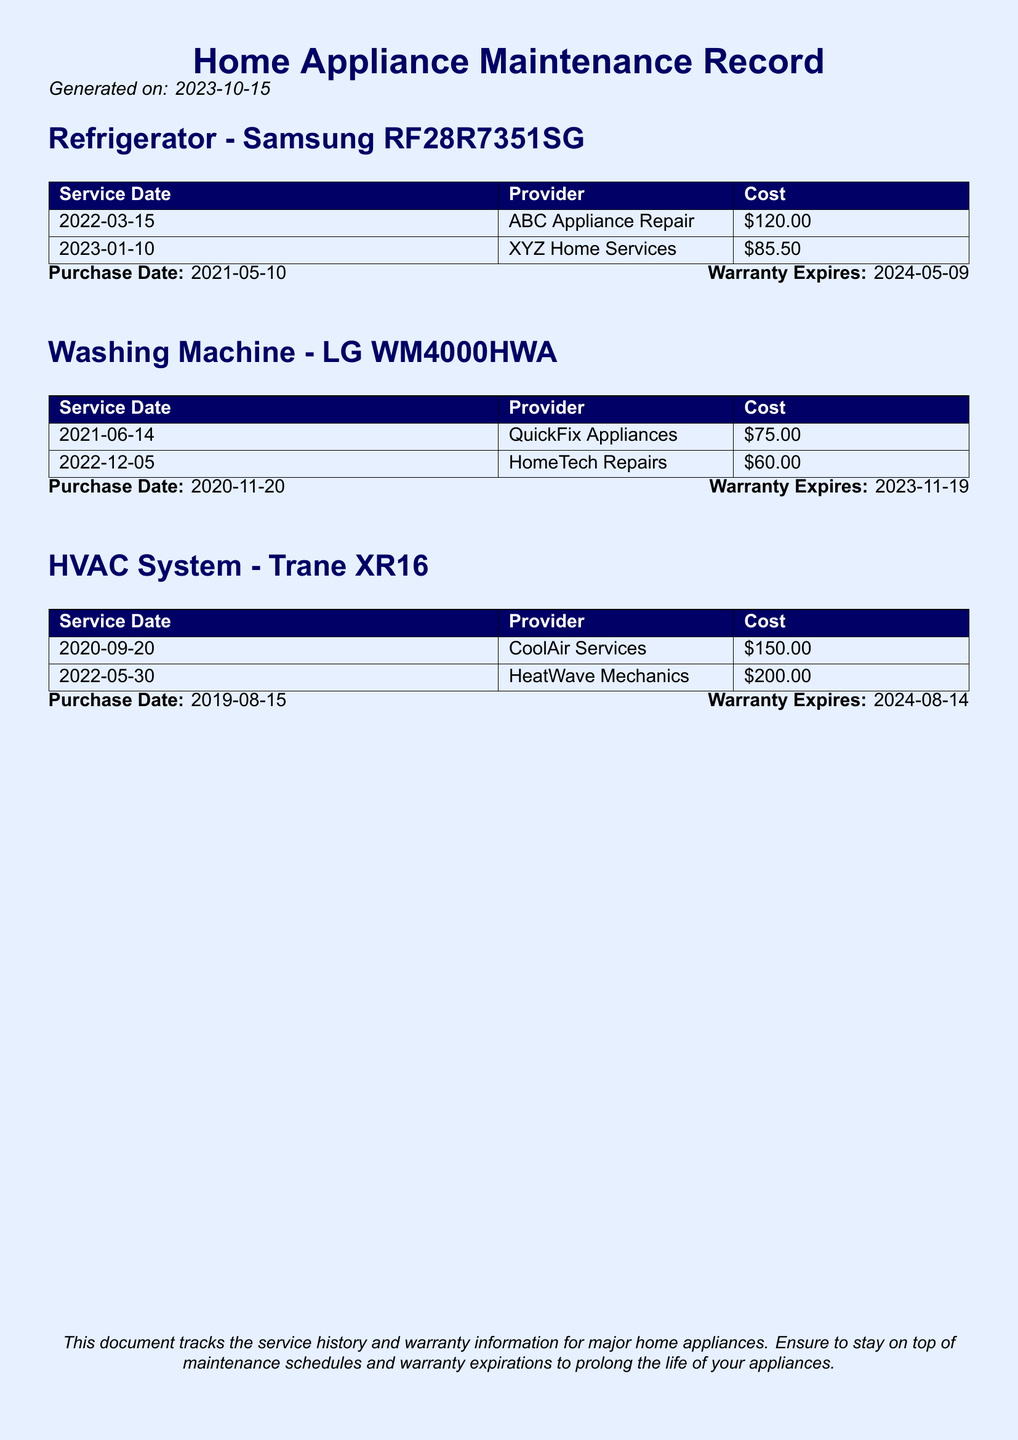What is the purchase date of the refrigerator? The purchase date is stated in the document as the date when the refrigerator was bought.
Answer: 2021-05-10 How much did the last service for the washing machine cost? The last service cost is the amount noted in the service history for the washing machine.
Answer: $60.00 What is the warranty expiration date for the HVAC system? The warranty expiration date is provided in the document for the HVAC system specifically.
Answer: 2024-08-14 How many service records are listed for the refrigerator? The number of service records refers to the count of entries under the refrigerator section.
Answer: 2 Which provider serviced the washing machine on June 14, 2021? The provider is mentioned next to the corresponding service date for the washing machine.
Answer: QuickFix Appliances What is the total cost of services for the HVAC system? The total cost is calculated by adding all the individual service costs listed for the HVAC system.
Answer: $350.00 Which appliance has an upcoming warranty expiration soonest? The upcoming warranty expiration refers to the appliance that has the nearest expiration date based on the information given.
Answer: Washing Machine What is the service provider for the last HVAC service? The last provider is identified in the service history for the HVAC system under the last service date.
Answer: HeatWave Mechanics 